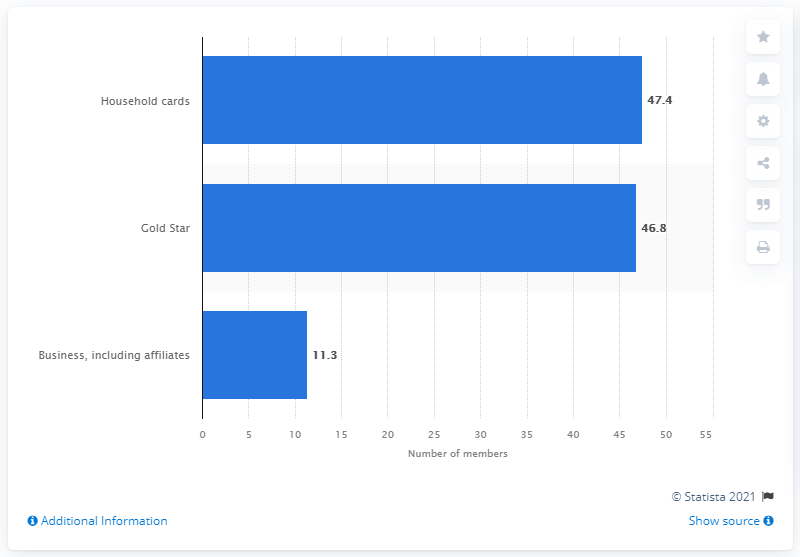Specify some key components in this picture. As of August 30, 2020, there were 47,400 Costco Gold Star members. 